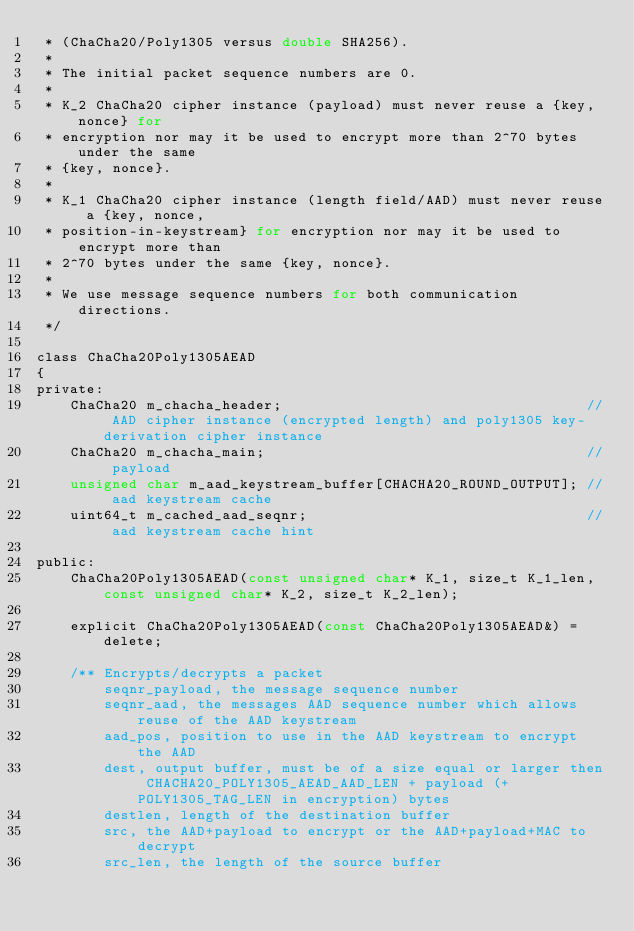Convert code to text. <code><loc_0><loc_0><loc_500><loc_500><_C_> * (ChaCha20/Poly1305 versus double SHA256).
 *
 * The initial packet sequence numbers are 0.
 *
 * K_2 ChaCha20 cipher instance (payload) must never reuse a {key, nonce} for
 * encryption nor may it be used to encrypt more than 2^70 bytes under the same
 * {key, nonce}.
 *
 * K_1 ChaCha20 cipher instance (length field/AAD) must never reuse a {key, nonce,
 * position-in-keystream} for encryption nor may it be used to encrypt more than
 * 2^70 bytes under the same {key, nonce}.
 *
 * We use message sequence numbers for both communication directions.
 */

class ChaCha20Poly1305AEAD
{
private:
    ChaCha20 m_chacha_header;                                    // AAD cipher instance (encrypted length) and poly1305 key-derivation cipher instance
    ChaCha20 m_chacha_main;                                      // payload
    unsigned char m_aad_keystream_buffer[CHACHA20_ROUND_OUTPUT]; // aad keystream cache
    uint64_t m_cached_aad_seqnr;                                 // aad keystream cache hint

public:
    ChaCha20Poly1305AEAD(const unsigned char* K_1, size_t K_1_len, const unsigned char* K_2, size_t K_2_len);

    explicit ChaCha20Poly1305AEAD(const ChaCha20Poly1305AEAD&) = delete;

    /** Encrypts/decrypts a packet
        seqnr_payload, the message sequence number
        seqnr_aad, the messages AAD sequence number which allows reuse of the AAD keystream
        aad_pos, position to use in the AAD keystream to encrypt the AAD
        dest, output buffer, must be of a size equal or larger then CHACHA20_POLY1305_AEAD_AAD_LEN + payload (+ POLY1305_TAG_LEN in encryption) bytes
        destlen, length of the destination buffer
        src, the AAD+payload to encrypt or the AAD+payload+MAC to decrypt
        src_len, the length of the source buffer</code> 